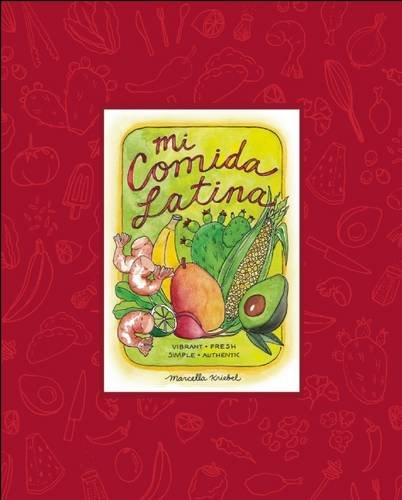Is this christianity book? No, this book is not related to Christianity. It specifically focuses on Latin American cuisine and belongs to the culinary genre of cookbooks. 